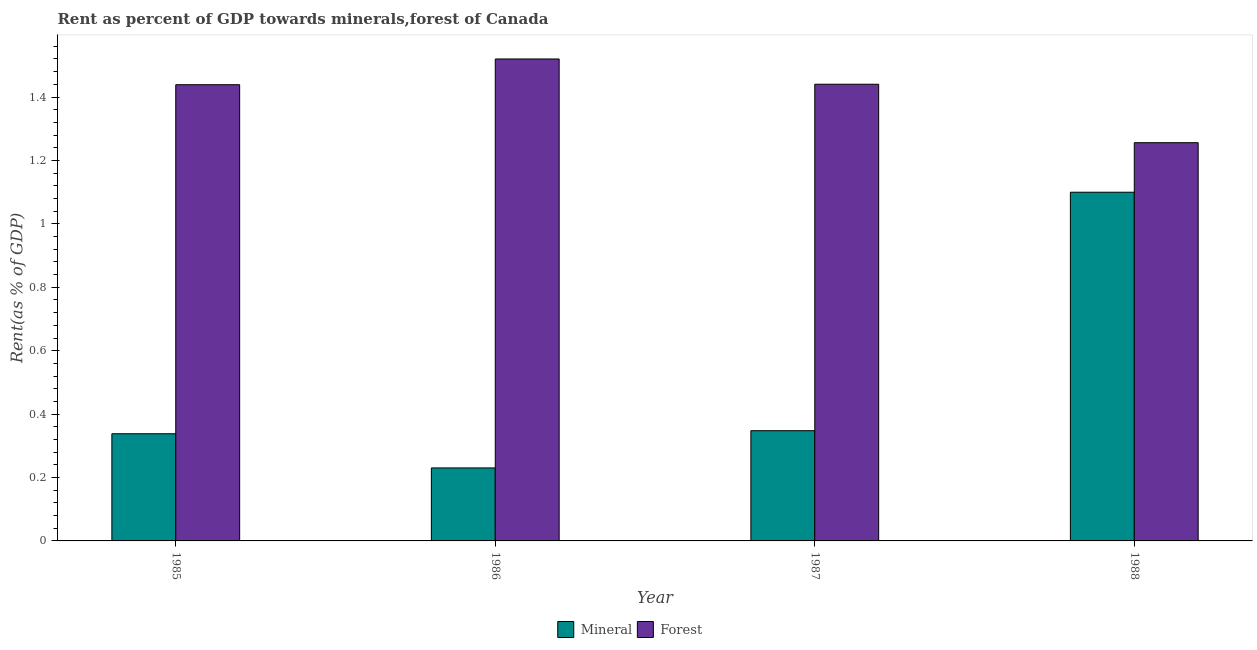How many groups of bars are there?
Offer a terse response. 4. Are the number of bars per tick equal to the number of legend labels?
Your answer should be compact. Yes. Are the number of bars on each tick of the X-axis equal?
Provide a succinct answer. Yes. How many bars are there on the 2nd tick from the left?
Make the answer very short. 2. How many bars are there on the 4th tick from the right?
Offer a terse response. 2. In how many cases, is the number of bars for a given year not equal to the number of legend labels?
Offer a very short reply. 0. What is the forest rent in 1988?
Offer a very short reply. 1.26. Across all years, what is the maximum mineral rent?
Make the answer very short. 1.1. Across all years, what is the minimum forest rent?
Provide a succinct answer. 1.26. In which year was the forest rent minimum?
Give a very brief answer. 1988. What is the total forest rent in the graph?
Keep it short and to the point. 5.66. What is the difference between the forest rent in 1985 and that in 1987?
Provide a succinct answer. -0. What is the difference between the mineral rent in 1988 and the forest rent in 1986?
Your response must be concise. 0.87. What is the average forest rent per year?
Keep it short and to the point. 1.41. In how many years, is the mineral rent greater than 1.4000000000000001 %?
Provide a succinct answer. 0. What is the ratio of the mineral rent in 1986 to that in 1988?
Give a very brief answer. 0.21. Is the difference between the mineral rent in 1985 and 1987 greater than the difference between the forest rent in 1985 and 1987?
Make the answer very short. No. What is the difference between the highest and the second highest forest rent?
Offer a terse response. 0.08. What is the difference between the highest and the lowest forest rent?
Offer a very short reply. 0.26. What does the 2nd bar from the left in 1985 represents?
Give a very brief answer. Forest. What does the 1st bar from the right in 1986 represents?
Offer a terse response. Forest. How many bars are there?
Offer a very short reply. 8. How many years are there in the graph?
Provide a short and direct response. 4. What is the difference between two consecutive major ticks on the Y-axis?
Your response must be concise. 0.2. Are the values on the major ticks of Y-axis written in scientific E-notation?
Provide a succinct answer. No. Does the graph contain any zero values?
Ensure brevity in your answer.  No. Where does the legend appear in the graph?
Offer a terse response. Bottom center. How are the legend labels stacked?
Offer a very short reply. Horizontal. What is the title of the graph?
Offer a terse response. Rent as percent of GDP towards minerals,forest of Canada. Does "% of gross capital formation" appear as one of the legend labels in the graph?
Give a very brief answer. No. What is the label or title of the X-axis?
Your response must be concise. Year. What is the label or title of the Y-axis?
Provide a succinct answer. Rent(as % of GDP). What is the Rent(as % of GDP) of Mineral in 1985?
Your response must be concise. 0.34. What is the Rent(as % of GDP) in Forest in 1985?
Your answer should be compact. 1.44. What is the Rent(as % of GDP) of Mineral in 1986?
Offer a terse response. 0.23. What is the Rent(as % of GDP) of Forest in 1986?
Offer a terse response. 1.52. What is the Rent(as % of GDP) of Mineral in 1987?
Keep it short and to the point. 0.35. What is the Rent(as % of GDP) of Forest in 1987?
Your answer should be compact. 1.44. What is the Rent(as % of GDP) in Mineral in 1988?
Your answer should be compact. 1.1. What is the Rent(as % of GDP) in Forest in 1988?
Your answer should be compact. 1.26. Across all years, what is the maximum Rent(as % of GDP) in Mineral?
Make the answer very short. 1.1. Across all years, what is the maximum Rent(as % of GDP) in Forest?
Provide a succinct answer. 1.52. Across all years, what is the minimum Rent(as % of GDP) in Mineral?
Provide a succinct answer. 0.23. Across all years, what is the minimum Rent(as % of GDP) of Forest?
Your answer should be very brief. 1.26. What is the total Rent(as % of GDP) of Mineral in the graph?
Provide a short and direct response. 2.02. What is the total Rent(as % of GDP) of Forest in the graph?
Your answer should be very brief. 5.66. What is the difference between the Rent(as % of GDP) of Mineral in 1985 and that in 1986?
Make the answer very short. 0.11. What is the difference between the Rent(as % of GDP) in Forest in 1985 and that in 1986?
Keep it short and to the point. -0.08. What is the difference between the Rent(as % of GDP) in Mineral in 1985 and that in 1987?
Offer a very short reply. -0.01. What is the difference between the Rent(as % of GDP) in Forest in 1985 and that in 1987?
Make the answer very short. -0. What is the difference between the Rent(as % of GDP) of Mineral in 1985 and that in 1988?
Make the answer very short. -0.76. What is the difference between the Rent(as % of GDP) of Forest in 1985 and that in 1988?
Your response must be concise. 0.18. What is the difference between the Rent(as % of GDP) of Mineral in 1986 and that in 1987?
Keep it short and to the point. -0.12. What is the difference between the Rent(as % of GDP) of Forest in 1986 and that in 1987?
Provide a short and direct response. 0.08. What is the difference between the Rent(as % of GDP) in Mineral in 1986 and that in 1988?
Your answer should be very brief. -0.87. What is the difference between the Rent(as % of GDP) in Forest in 1986 and that in 1988?
Keep it short and to the point. 0.26. What is the difference between the Rent(as % of GDP) in Mineral in 1987 and that in 1988?
Your response must be concise. -0.75. What is the difference between the Rent(as % of GDP) in Forest in 1987 and that in 1988?
Provide a succinct answer. 0.18. What is the difference between the Rent(as % of GDP) of Mineral in 1985 and the Rent(as % of GDP) of Forest in 1986?
Keep it short and to the point. -1.18. What is the difference between the Rent(as % of GDP) in Mineral in 1985 and the Rent(as % of GDP) in Forest in 1987?
Keep it short and to the point. -1.1. What is the difference between the Rent(as % of GDP) in Mineral in 1985 and the Rent(as % of GDP) in Forest in 1988?
Your response must be concise. -0.92. What is the difference between the Rent(as % of GDP) in Mineral in 1986 and the Rent(as % of GDP) in Forest in 1987?
Keep it short and to the point. -1.21. What is the difference between the Rent(as % of GDP) of Mineral in 1986 and the Rent(as % of GDP) of Forest in 1988?
Offer a terse response. -1.03. What is the difference between the Rent(as % of GDP) in Mineral in 1987 and the Rent(as % of GDP) in Forest in 1988?
Provide a short and direct response. -0.91. What is the average Rent(as % of GDP) in Mineral per year?
Make the answer very short. 0.5. What is the average Rent(as % of GDP) in Forest per year?
Your answer should be compact. 1.41. In the year 1985, what is the difference between the Rent(as % of GDP) of Mineral and Rent(as % of GDP) of Forest?
Provide a short and direct response. -1.1. In the year 1986, what is the difference between the Rent(as % of GDP) of Mineral and Rent(as % of GDP) of Forest?
Offer a very short reply. -1.29. In the year 1987, what is the difference between the Rent(as % of GDP) in Mineral and Rent(as % of GDP) in Forest?
Make the answer very short. -1.09. In the year 1988, what is the difference between the Rent(as % of GDP) of Mineral and Rent(as % of GDP) of Forest?
Your answer should be compact. -0.16. What is the ratio of the Rent(as % of GDP) in Mineral in 1985 to that in 1986?
Make the answer very short. 1.47. What is the ratio of the Rent(as % of GDP) of Forest in 1985 to that in 1986?
Provide a succinct answer. 0.95. What is the ratio of the Rent(as % of GDP) of Mineral in 1985 to that in 1987?
Provide a succinct answer. 0.97. What is the ratio of the Rent(as % of GDP) in Mineral in 1985 to that in 1988?
Give a very brief answer. 0.31. What is the ratio of the Rent(as % of GDP) of Forest in 1985 to that in 1988?
Provide a short and direct response. 1.15. What is the ratio of the Rent(as % of GDP) in Mineral in 1986 to that in 1987?
Offer a terse response. 0.66. What is the ratio of the Rent(as % of GDP) in Forest in 1986 to that in 1987?
Offer a very short reply. 1.06. What is the ratio of the Rent(as % of GDP) of Mineral in 1986 to that in 1988?
Your response must be concise. 0.21. What is the ratio of the Rent(as % of GDP) in Forest in 1986 to that in 1988?
Your answer should be compact. 1.21. What is the ratio of the Rent(as % of GDP) of Mineral in 1987 to that in 1988?
Give a very brief answer. 0.32. What is the ratio of the Rent(as % of GDP) of Forest in 1987 to that in 1988?
Your answer should be very brief. 1.15. What is the difference between the highest and the second highest Rent(as % of GDP) of Mineral?
Your response must be concise. 0.75. What is the difference between the highest and the second highest Rent(as % of GDP) in Forest?
Keep it short and to the point. 0.08. What is the difference between the highest and the lowest Rent(as % of GDP) in Mineral?
Your response must be concise. 0.87. What is the difference between the highest and the lowest Rent(as % of GDP) of Forest?
Make the answer very short. 0.26. 